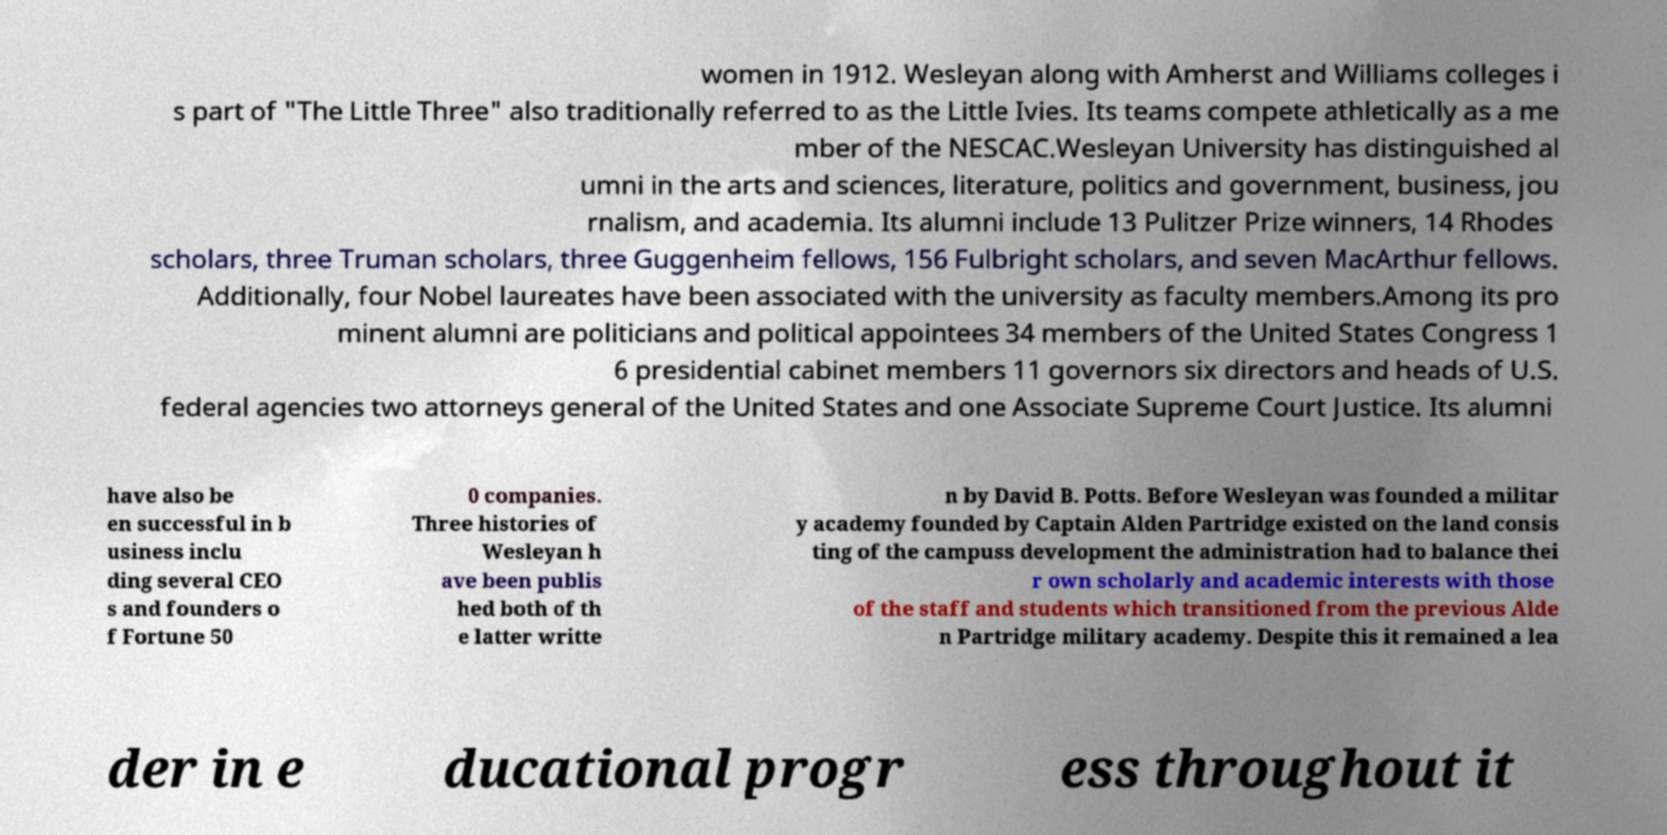What messages or text are displayed in this image? I need them in a readable, typed format. women in 1912. Wesleyan along with Amherst and Williams colleges i s part of "The Little Three" also traditionally referred to as the Little Ivies. Its teams compete athletically as a me mber of the NESCAC.Wesleyan University has distinguished al umni in the arts and sciences, literature, politics and government, business, jou rnalism, and academia. Its alumni include 13 Pulitzer Prize winners, 14 Rhodes scholars, three Truman scholars, three Guggenheim fellows, 156 Fulbright scholars, and seven MacArthur fellows. Additionally, four Nobel laureates have been associated with the university as faculty members.Among its pro minent alumni are politicians and political appointees 34 members of the United States Congress 1 6 presidential cabinet members 11 governors six directors and heads of U.S. federal agencies two attorneys general of the United States and one Associate Supreme Court Justice. Its alumni have also be en successful in b usiness inclu ding several CEO s and founders o f Fortune 50 0 companies. Three histories of Wesleyan h ave been publis hed both of th e latter writte n by David B. Potts. Before Wesleyan was founded a militar y academy founded by Captain Alden Partridge existed on the land consis ting of the campuss development the administration had to balance thei r own scholarly and academic interests with those of the staff and students which transitioned from the previous Alde n Partridge military academy. Despite this it remained a lea der in e ducational progr ess throughout it 